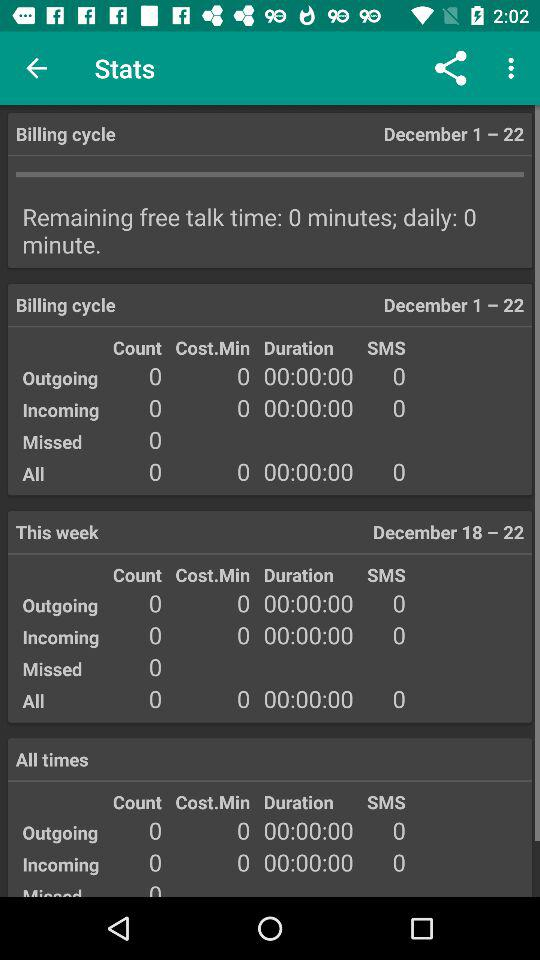How many calls did we miss between December 18 and December 22? You missed 0 calls between December 18 and December 22. 